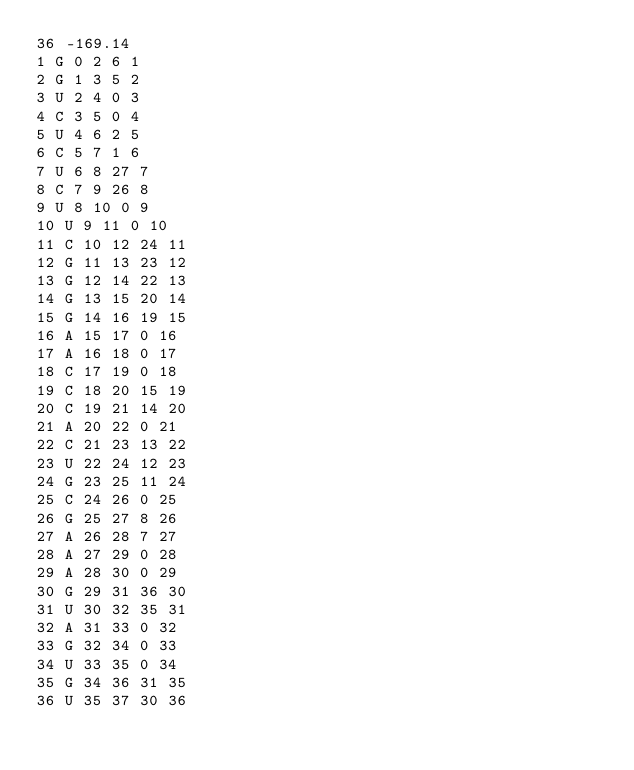Convert code to text. <code><loc_0><loc_0><loc_500><loc_500><_XML_>36 -169.14    
1 G 0 2 6 1
2 G 1 3 5 2
3 U 2 4 0 3
4 C 3 5 0 4
5 U 4 6 2 5
6 C 5 7 1 6
7 U 6 8 27 7
8 C 7 9 26 8
9 U 8 10 0 9
10 U 9 11 0 10
11 C 10 12 24 11
12 G 11 13 23 12
13 G 12 14 22 13
14 G 13 15 20 14
15 G 14 16 19 15
16 A 15 17 0 16
17 A 16 18 0 17
18 C 17 19 0 18
19 C 18 20 15 19
20 C 19 21 14 20
21 A 20 22 0 21
22 C 21 23 13 22
23 U 22 24 12 23
24 G 23 25 11 24
25 C 24 26 0 25
26 G 25 27 8 26
27 A 26 28 7 27
28 A 27 29 0 28
29 A 28 30 0 29
30 G 29 31 36 30
31 U 30 32 35 31
32 A 31 33 0 32
33 G 32 34 0 33
34 U 33 35 0 34
35 G 34 36 31 35
36 U 35 37 30 36
</code> 